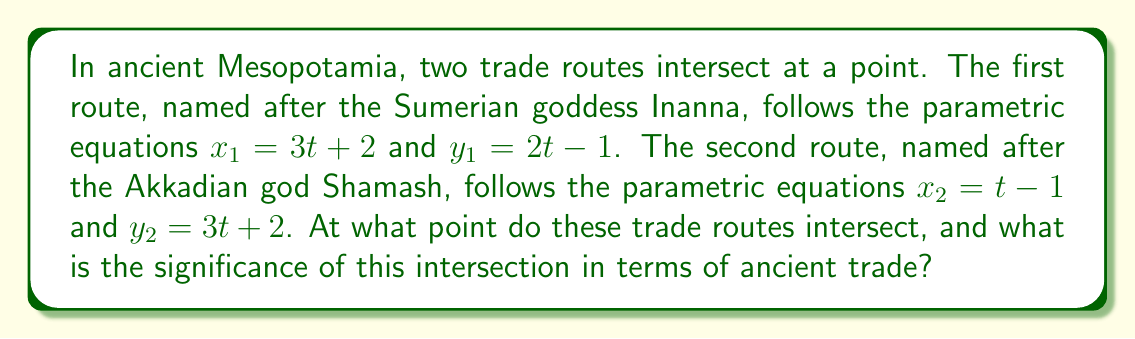Help me with this question. To find the intersection point of these two trade routes, we need to solve the system of equations:

$$\begin{cases}
3t + 2 = s - 1 \\
2t - 1 = 3s + 2
\end{cases}$$

Where $t$ is the parameter for the Inanna route and $s$ is the parameter for the Shamash route.

Step 1: Solve the first equation for $s$
$s = 3t + 3$

Step 2: Substitute this expression for $s$ into the second equation
$2t - 1 = 3(3t + 3) + 2$
$2t - 1 = 9t + 11$

Step 3: Solve for $t$
$-7t = 12$
$t = -\frac{12}{7}$

Step 4: Substitute this value of $t$ back into the equations for $x_1$ and $y_1$ (or $x_2$ and $y_2$)
$x = 3(-\frac{12}{7}) + 2 = -\frac{36}{7} + 2 = -\frac{22}{7}$
$y = 2(-\frac{12}{7}) - 1 = -\frac{24}{7} - 1 = -\frac{31}{7}$

Therefore, the intersection point is $(-\frac{22}{7}, -\frac{31}{7})$.

The significance of this intersection in terms of ancient trade is that it represents a crucial meeting point between two major trade routes. Such intersections often became important marketplaces or cities, as they allowed merchants from different regions to exchange goods and information. The names of the routes, derived from Sumerian and Akkadian deities, reflect the cultural and religious importance of trade in ancient Mesopotamian civilization.
Answer: The trade routes intersect at the point $(-\frac{22}{7}, -\frac{31}{7})$. 